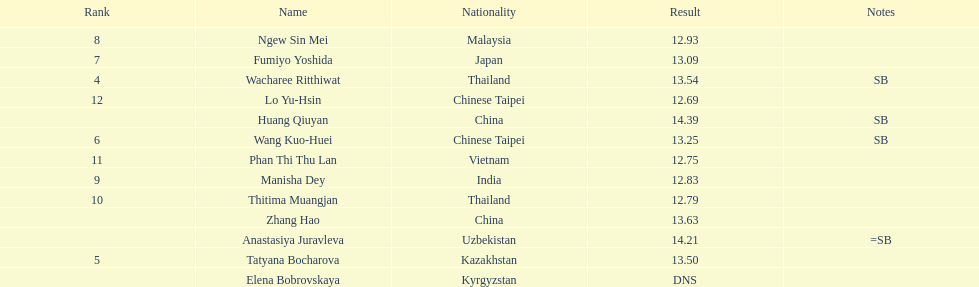How many competitors had less than 13.00 points? 6. 